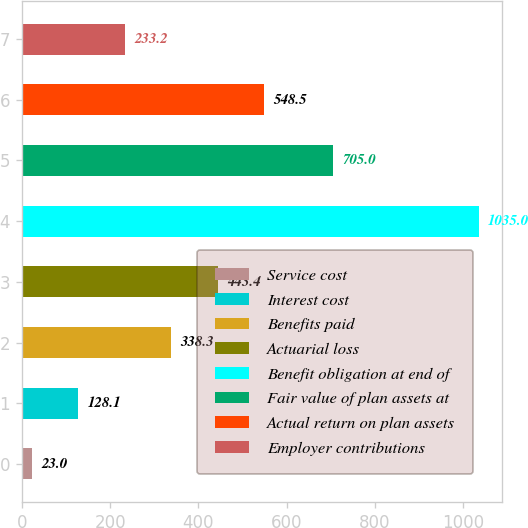Convert chart to OTSL. <chart><loc_0><loc_0><loc_500><loc_500><bar_chart><fcel>Service cost<fcel>Interest cost<fcel>Benefits paid<fcel>Actuarial loss<fcel>Benefit obligation at end of<fcel>Fair value of plan assets at<fcel>Actual return on plan assets<fcel>Employer contributions<nl><fcel>23<fcel>128.1<fcel>338.3<fcel>443.4<fcel>1035<fcel>705<fcel>548.5<fcel>233.2<nl></chart> 